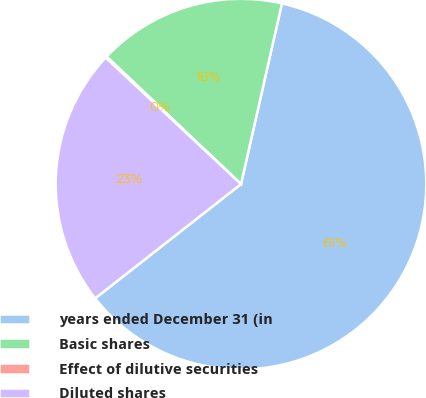Convert chart to OTSL. <chart><loc_0><loc_0><loc_500><loc_500><pie_chart><fcel>years ended December 31 (in<fcel>Basic shares<fcel>Effect of dilutive securities<fcel>Diluted shares<nl><fcel>60.87%<fcel>16.46%<fcel>0.12%<fcel>22.54%<nl></chart> 